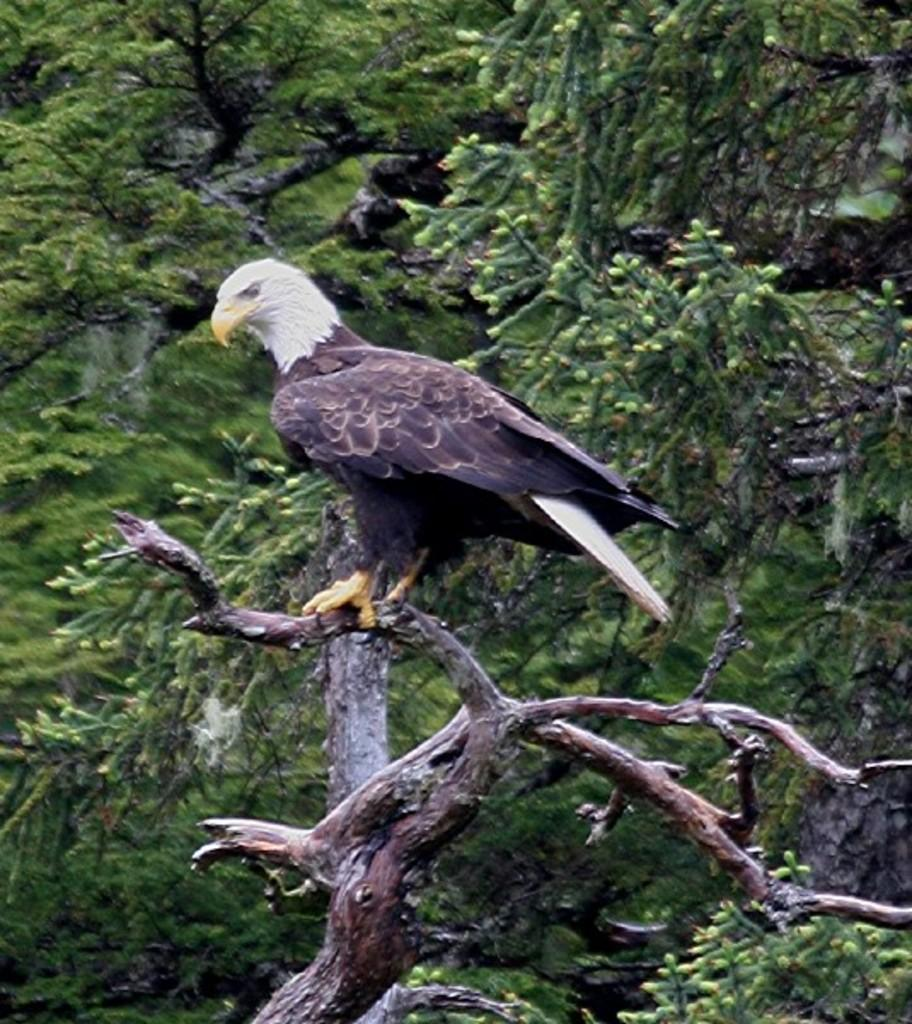What animal is featured in the image? There is an eagle in the image. Where is the eagle located? The eagle is on a branch of a tree. What can be seen in the background of the image? There are trees visible in the background of the image. What type of bone can be seen in the eagle's talons in the image? There is no bone present in the image; the eagle is simply perched on a branch. 